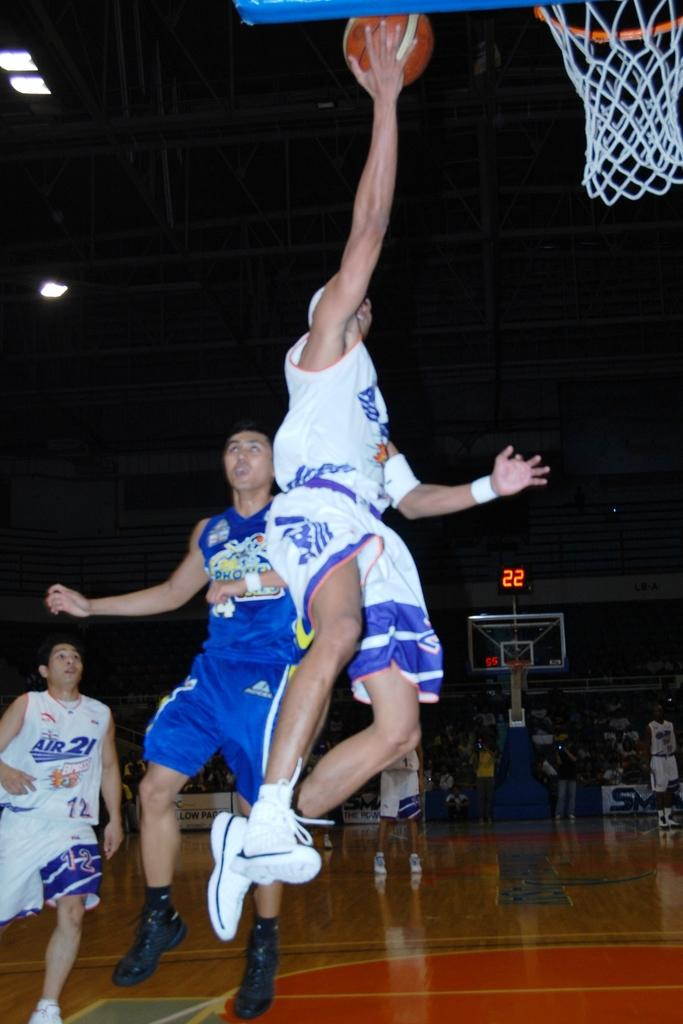<image>
Write a terse but informative summary of the picture. A basketball player for the Air 21 team goes for a basket. 